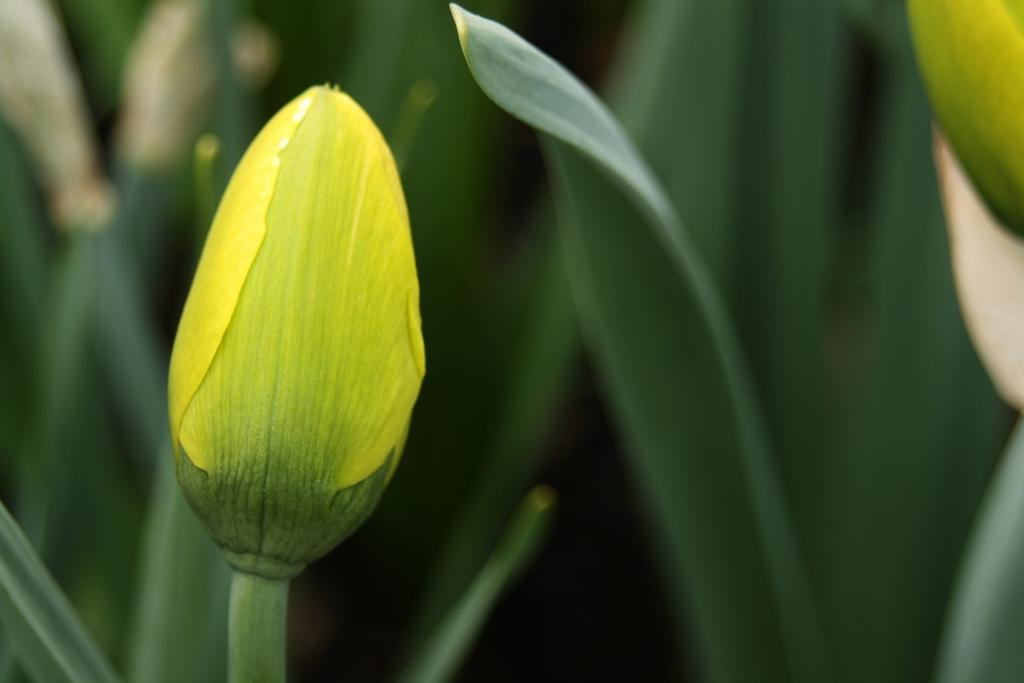What is the main subject in the foreground of the image? There is a yellow bud in the foreground of the image. What else can be seen in the image besides the yellow bud? The image contains leaves of the plant. Are there any other buds visible in the image? Yes, there is another bud on the top right side of the image. What type of whistle can be heard in the background of the image? There is no whistle present in the image, as it is a still image of a plant. 